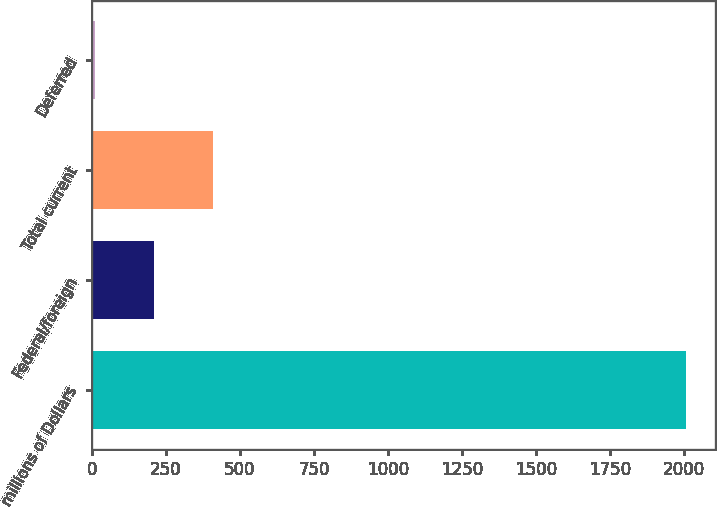Convert chart. <chart><loc_0><loc_0><loc_500><loc_500><bar_chart><fcel>millions of Dollars<fcel>Federal/foreign<fcel>Total current<fcel>Deferred<nl><fcel>2007<fcel>209.7<fcel>409.4<fcel>10<nl></chart> 